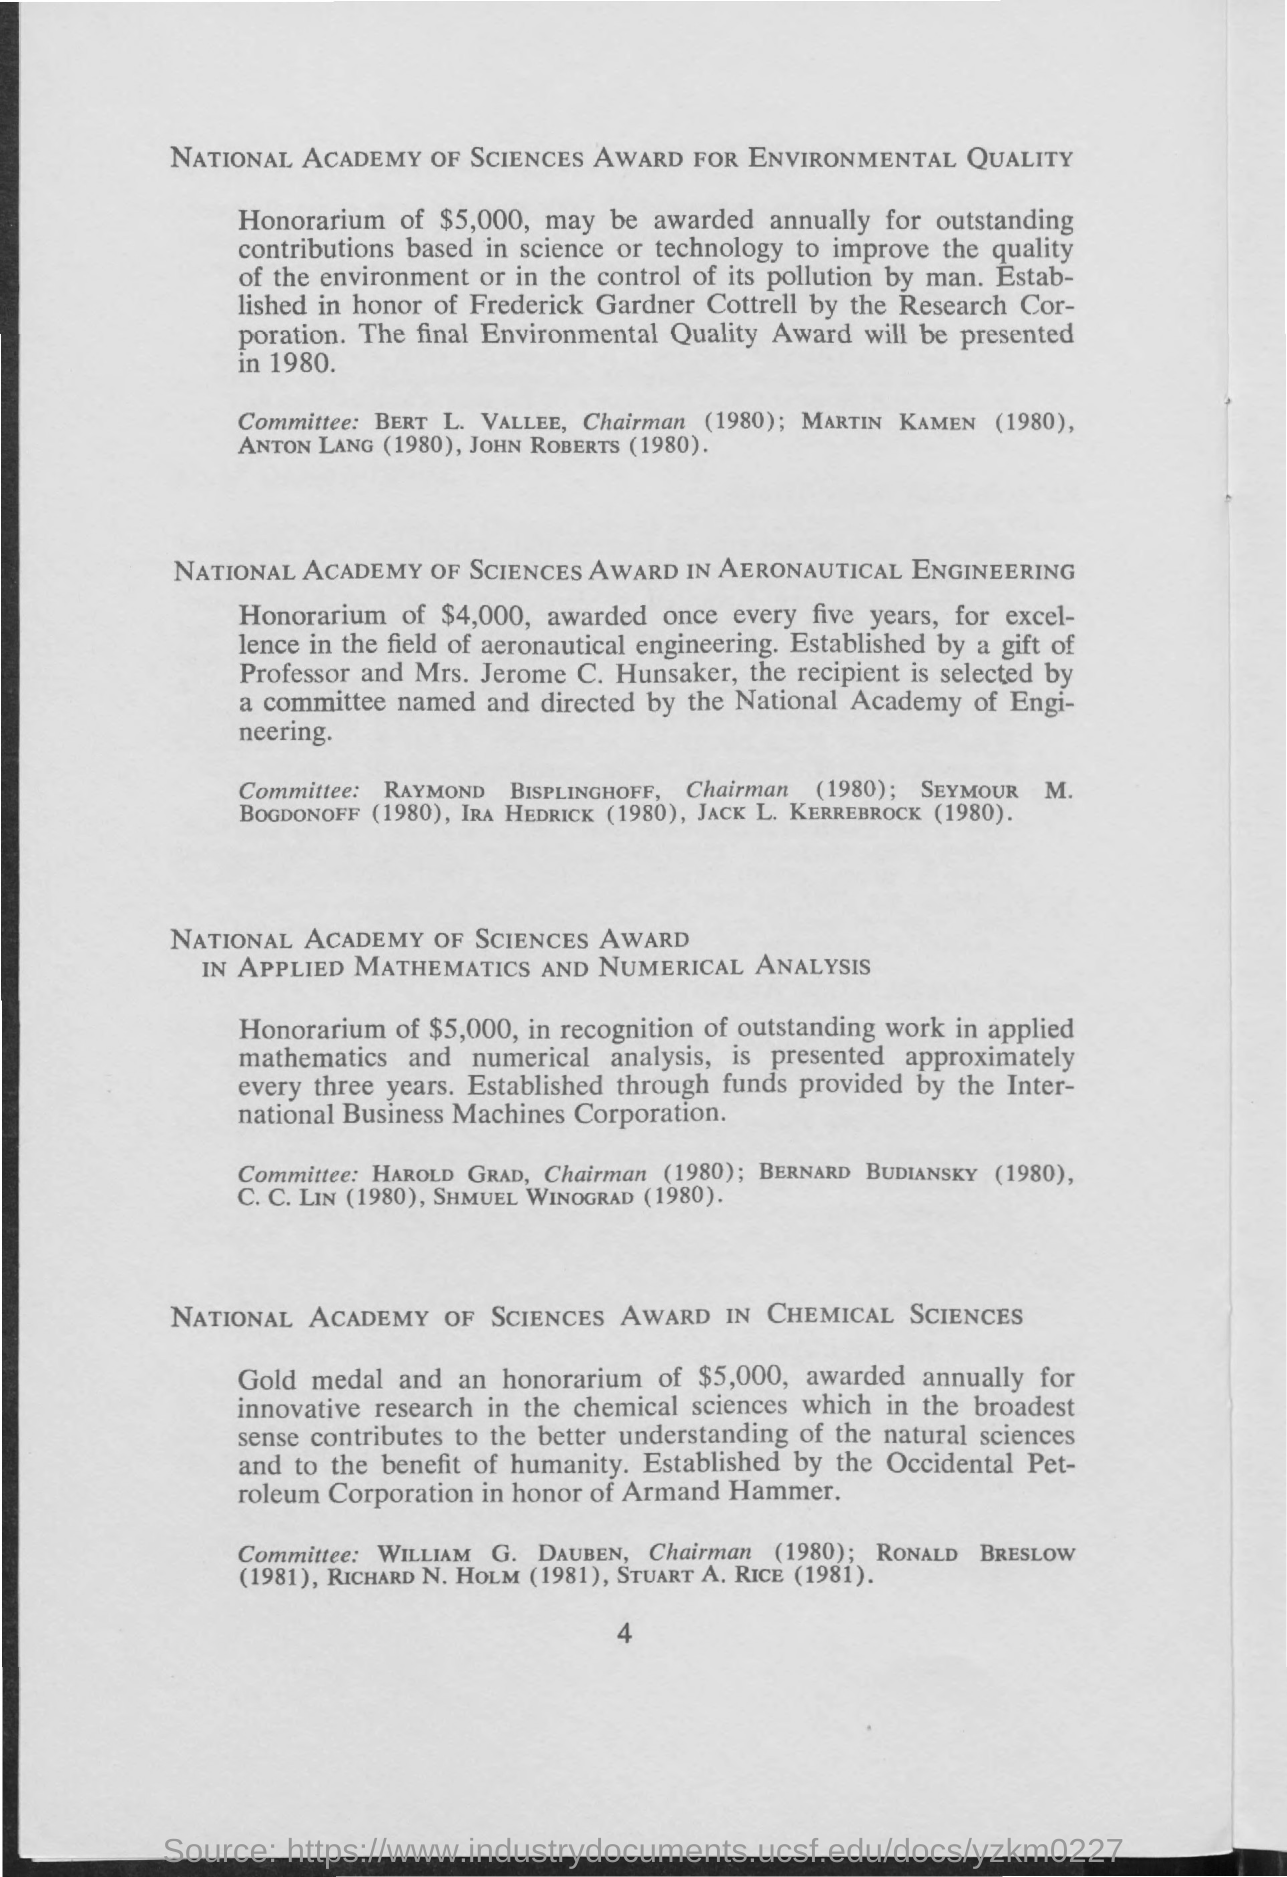Outline some significant characteristics in this image. The honorarium for excellence in the field of aeronautical engineering is $4,000. I, [Your Name], solemnly declare that the honorarium for outstanding contributions based in science or technology is $5,000. 